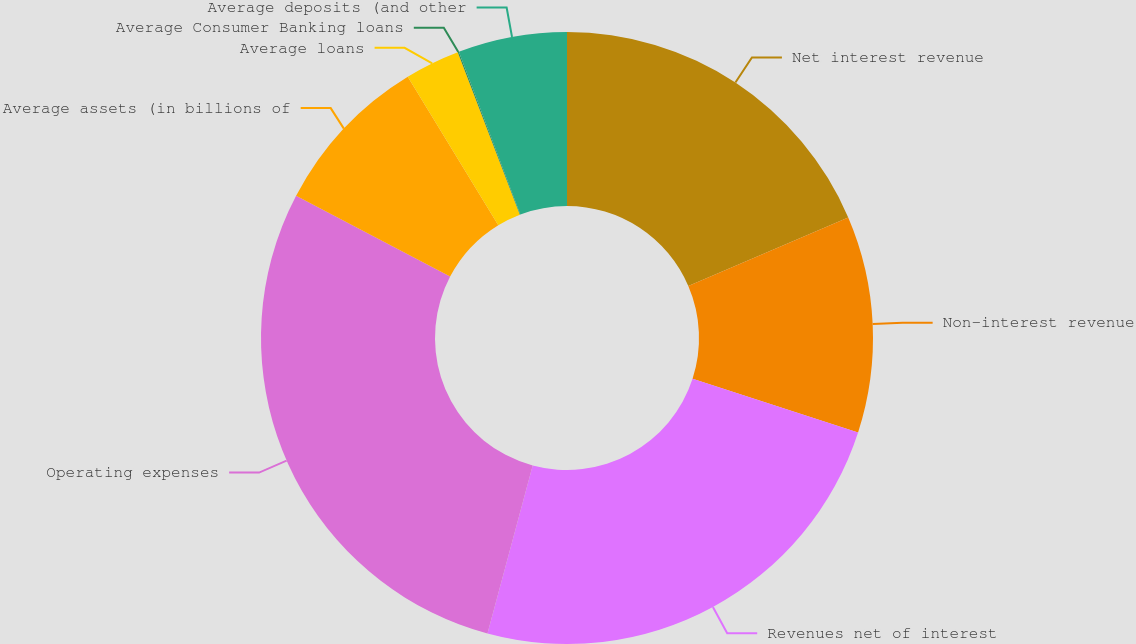Convert chart to OTSL. <chart><loc_0><loc_0><loc_500><loc_500><pie_chart><fcel>Net interest revenue<fcel>Non-interest revenue<fcel>Revenues net of interest<fcel>Operating expenses<fcel>Average assets (in billions of<fcel>Average loans<fcel>Average Consumer Banking loans<fcel>Average deposits (and other<nl><fcel>18.55%<fcel>11.44%<fcel>24.19%<fcel>28.51%<fcel>8.59%<fcel>2.9%<fcel>0.06%<fcel>5.75%<nl></chart> 